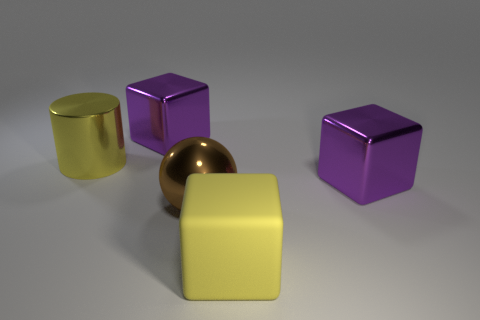Subtract all big purple blocks. How many blocks are left? 1 Subtract all purple cubes. How many cubes are left? 1 Add 2 shiny things. How many objects exist? 7 Subtract all cylinders. How many objects are left? 4 Subtract 1 spheres. How many spheres are left? 0 Add 5 spheres. How many spheres are left? 6 Add 2 matte objects. How many matte objects exist? 3 Subtract 1 yellow cylinders. How many objects are left? 4 Subtract all cyan cubes. Subtract all gray cylinders. How many cubes are left? 3 Subtract all green cylinders. How many yellow blocks are left? 1 